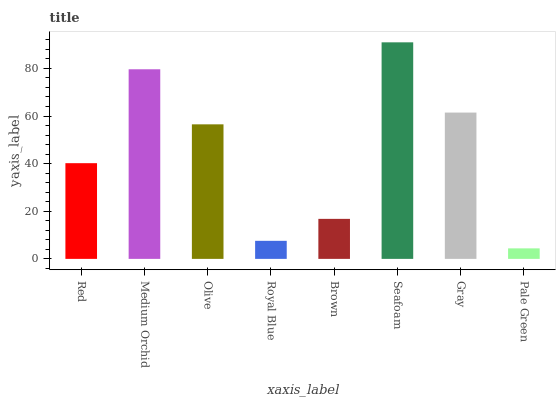Is Pale Green the minimum?
Answer yes or no. Yes. Is Seafoam the maximum?
Answer yes or no. Yes. Is Medium Orchid the minimum?
Answer yes or no. No. Is Medium Orchid the maximum?
Answer yes or no. No. Is Medium Orchid greater than Red?
Answer yes or no. Yes. Is Red less than Medium Orchid?
Answer yes or no. Yes. Is Red greater than Medium Orchid?
Answer yes or no. No. Is Medium Orchid less than Red?
Answer yes or no. No. Is Olive the high median?
Answer yes or no. Yes. Is Red the low median?
Answer yes or no. Yes. Is Red the high median?
Answer yes or no. No. Is Seafoam the low median?
Answer yes or no. No. 